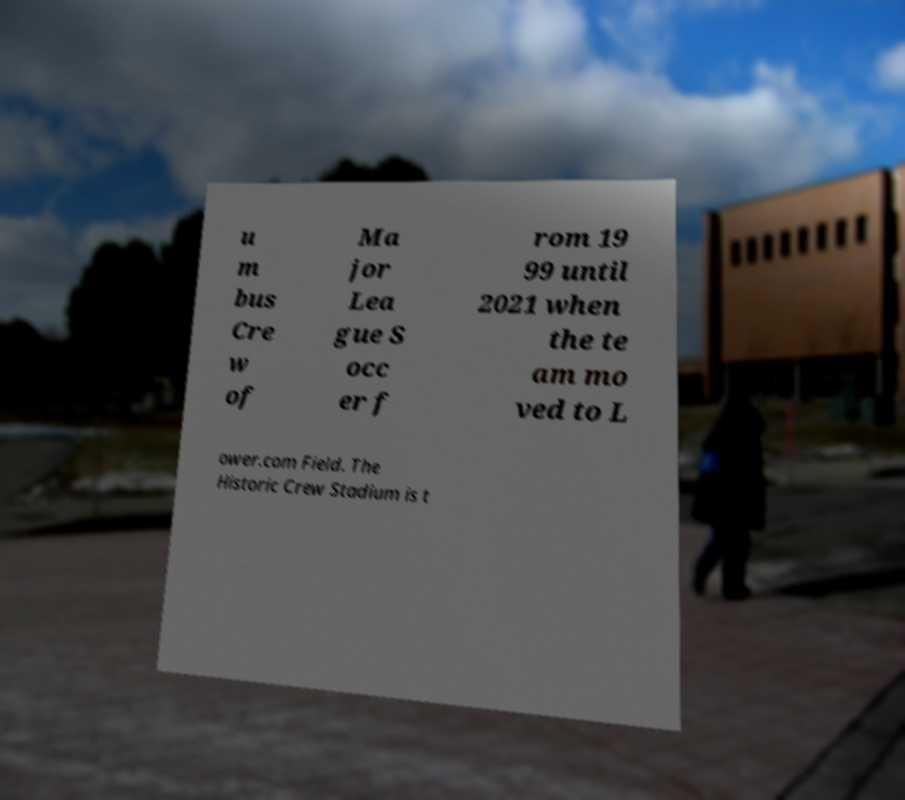Can you read and provide the text displayed in the image?This photo seems to have some interesting text. Can you extract and type it out for me? u m bus Cre w of Ma jor Lea gue S occ er f rom 19 99 until 2021 when the te am mo ved to L ower.com Field. The Historic Crew Stadium is t 